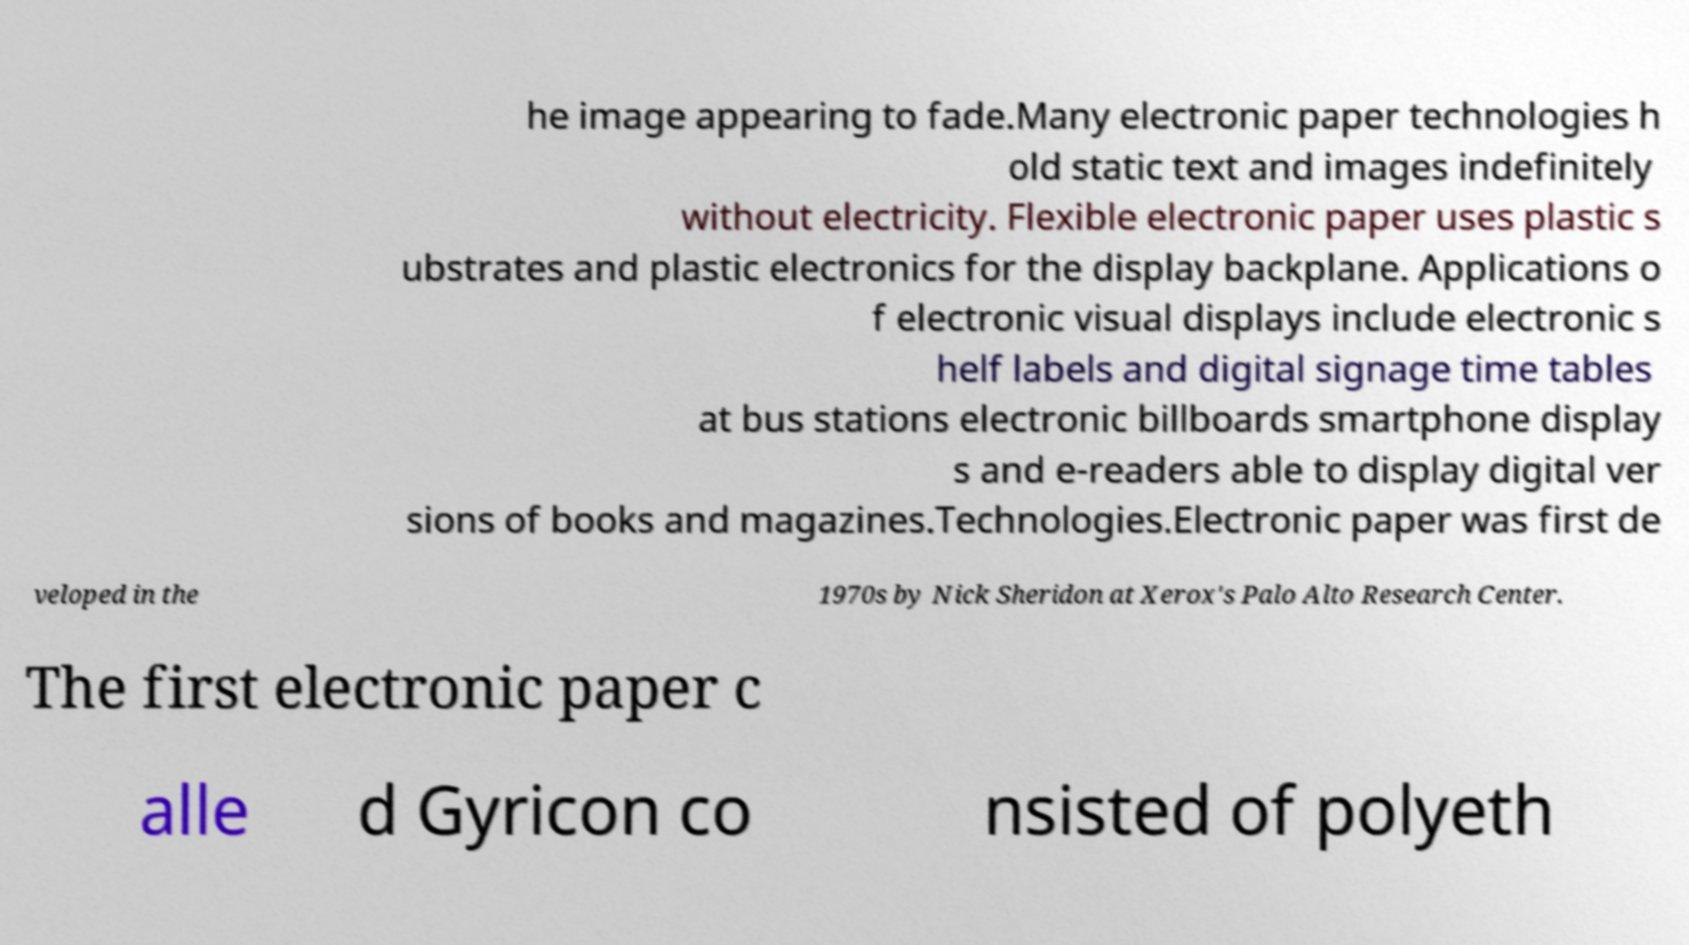Please read and relay the text visible in this image. What does it say? he image appearing to fade.Many electronic paper technologies h old static text and images indefinitely without electricity. Flexible electronic paper uses plastic s ubstrates and plastic electronics for the display backplane. Applications o f electronic visual displays include electronic s helf labels and digital signage time tables at bus stations electronic billboards smartphone display s and e-readers able to display digital ver sions of books and magazines.Technologies.Electronic paper was first de veloped in the 1970s by Nick Sheridon at Xerox's Palo Alto Research Center. The first electronic paper c alle d Gyricon co nsisted of polyeth 